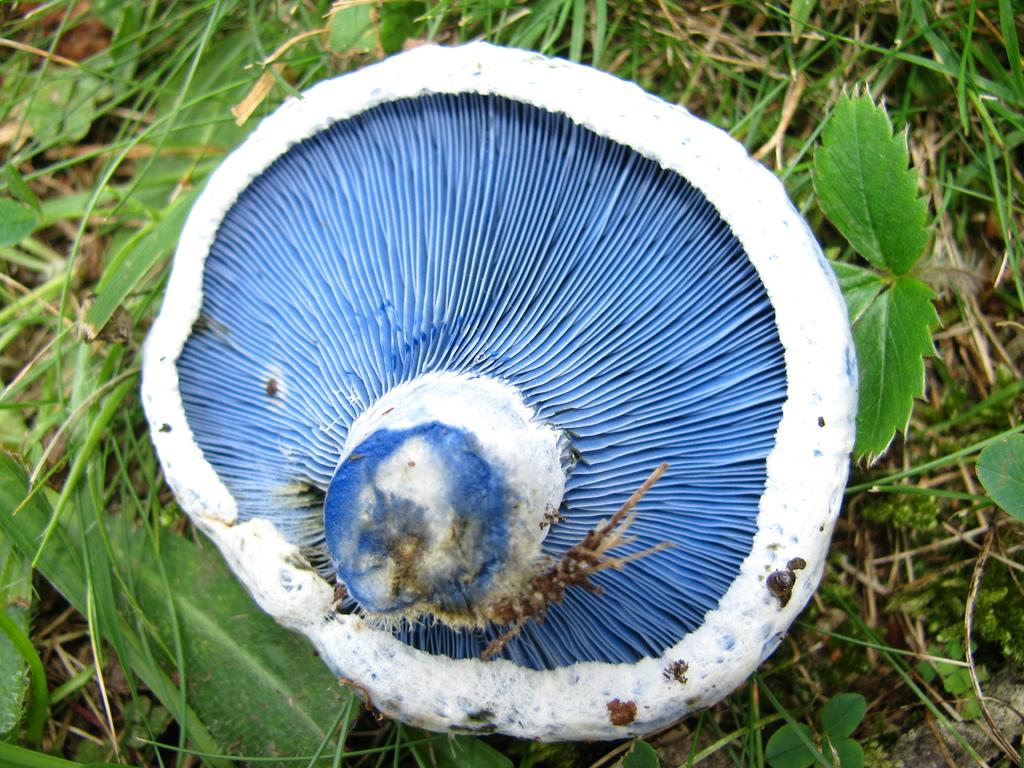What type of plant can be seen in the image? There is a mushroom in the image. What other natural elements are present in the image? There are leaves and grass in the image. Can you hear the noise of the lake in the image? There is no lake present in the image, so it is not possible to hear any noise associated with it. 